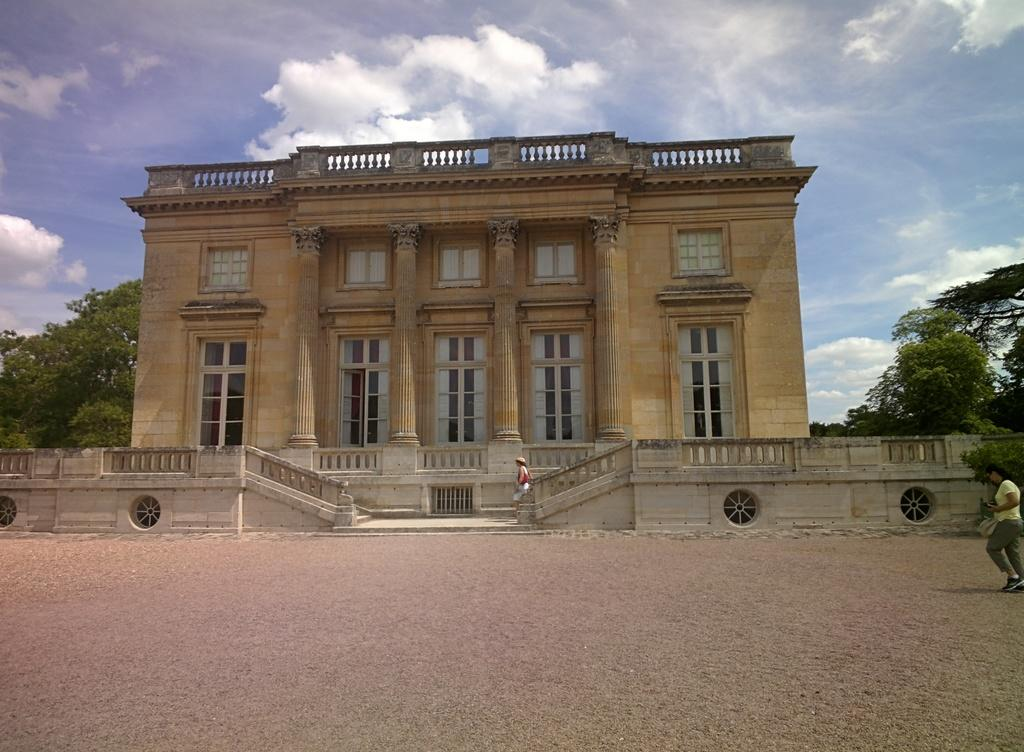How many people are present in the image? There are 2 people in the image. What can be seen in the background of the image? There is a building in the background of the image. What features does the building have? The building has railing and stairs. What type of vegetation is present on either side of the image? There are trees on either side of the image. What is visible at the top of the image? The sky is visible at the top of the image. What type of tin can be seen being offered by the light in the image? There is no tin or light present in the image. 